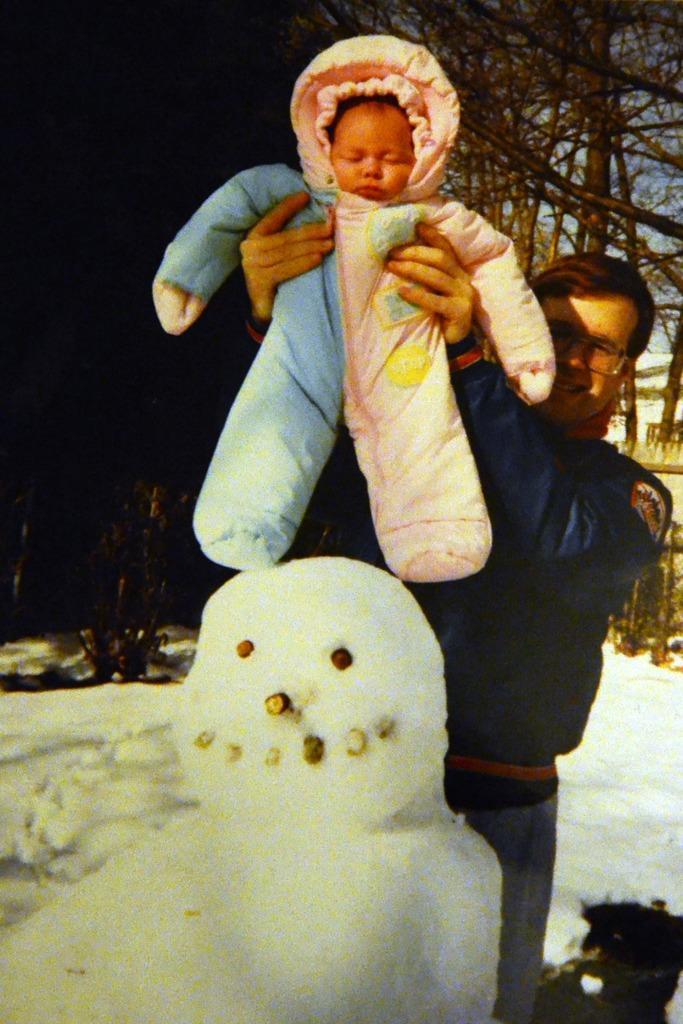Please provide a concise description of this image. This image consists of a man holding a small kid. At the bottom, there is a snowman made up of snow. In the background, there are trees. 